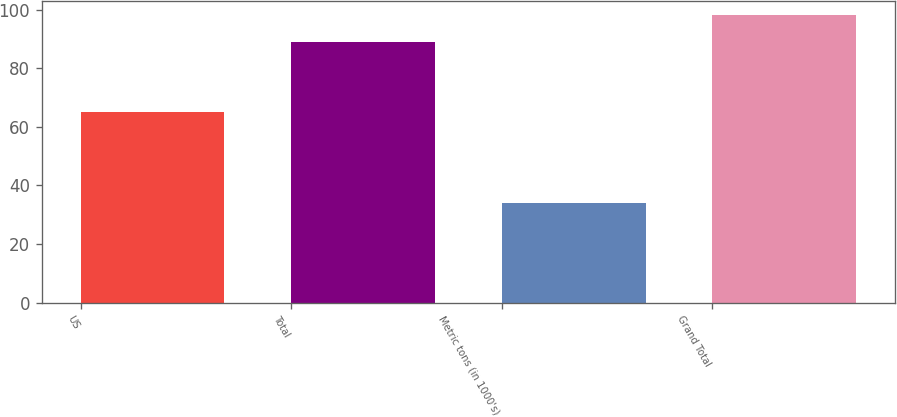Convert chart. <chart><loc_0><loc_0><loc_500><loc_500><bar_chart><fcel>US<fcel>Total<fcel>Metric tons (in 1000's)<fcel>Grand Total<nl><fcel>65<fcel>89<fcel>34<fcel>98<nl></chart> 